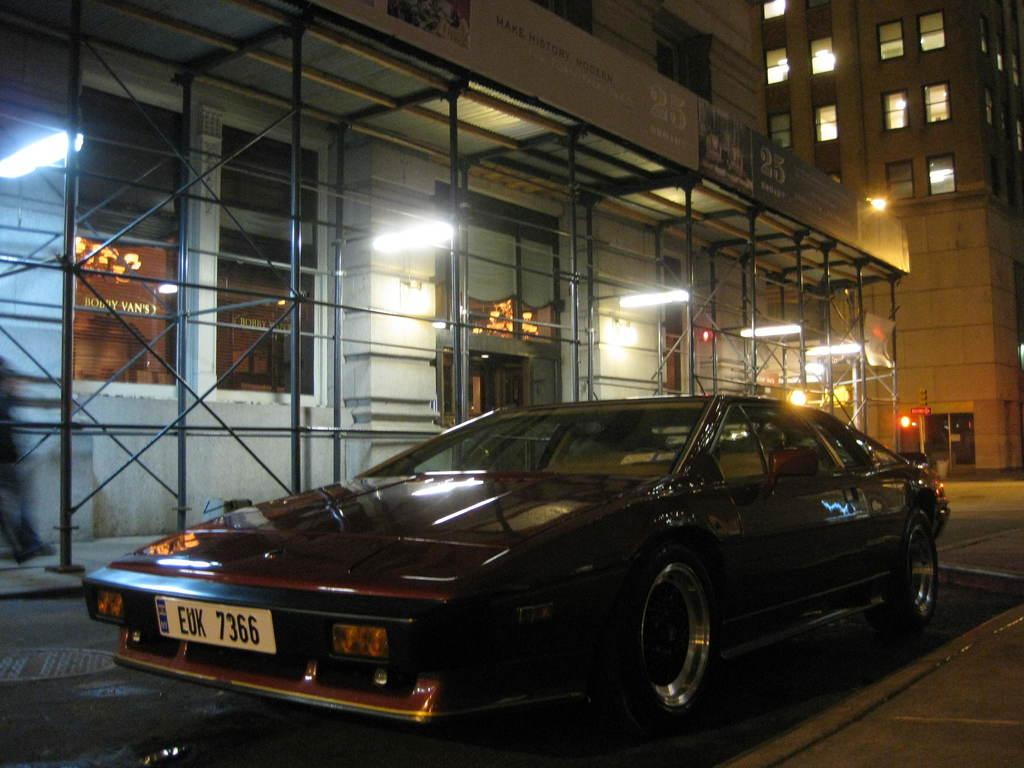What is the main subject in the center of the image? There is a car in the center of the image. What can be seen in the distance behind the car? There are buildings and lights in the background of the image. What structures are visible in the image? There are poles visible in the image. What is at the bottom of the image? There is a walkway at the bottom of the image. What type of bead is hanging from the car in the image? There is no bead hanging from the car in the image. What fruit can be seen growing on the walkway in the image? There are no fruits, including cherries, growing on the walkway in the image. 